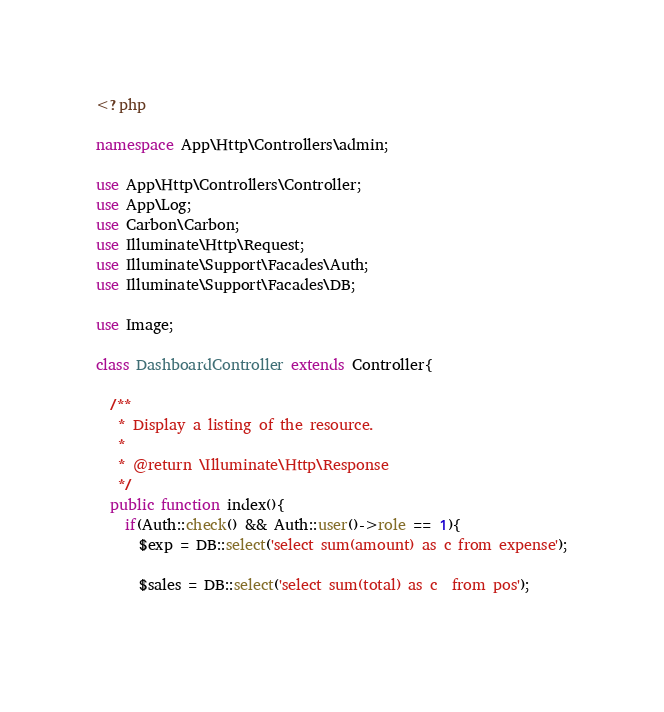<code> <loc_0><loc_0><loc_500><loc_500><_PHP_><?php

namespace App\Http\Controllers\admin;

use App\Http\Controllers\Controller;
use App\Log;
use Carbon\Carbon;
use Illuminate\Http\Request;
use Illuminate\Support\Facades\Auth;
use Illuminate\Support\Facades\DB;

use Image;

class DashboardController extends Controller{
  
  /**
   * Display a listing of the resource.
   *
   * @return \Illuminate\Http\Response
   */
  public function index(){
    if(Auth::check() && Auth::user()->role == 1){
      $exp = DB::select('select sum(amount) as c from expense');
      
      $sales = DB::select('select sum(total) as c  from pos');
      </code> 